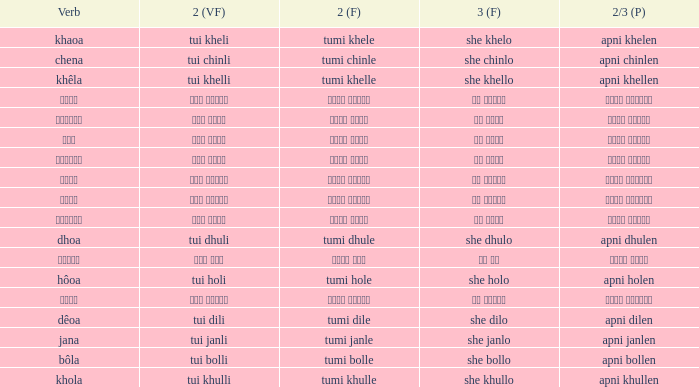What is the 2nd verb for Khola? Tumi khulle. 